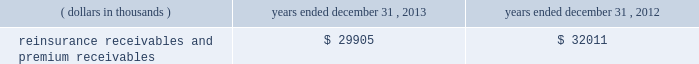In addition , the company has reclassified the following amounts from 201cdistributions from other invested assets 201d included in cash flows from investing activities to 201cdistribution of limited partnership income 201d included in cash flows from operations for interim reporting periods of 2013 : $ 33686 thousand for the three months ended march 31 , 2013 ; $ 9409 thousand and $ 43095 thousand for the three months and six months ended june 30 , 2013 , respectively ; and $ 5638 thousand and $ 48733 thousand for the three months and nine months ended september 30 , 2013 , respectively .
Investments .
Fixed maturity and equity security investments available for sale , at market value , reflect unrealized appreciation and depreciation , as a result of temporary changes in market value during the period , in shareholders 2019 equity , net of income taxes in 201caccumulated other comprehensive income ( loss ) 201d in the consolidated balance sheets .
Fixed maturity and equity securities carried at fair value reflect fair value re- measurements as net realized capital gains and losses in the consolidated statements of operations and comprehensive income ( loss ) .
The company records changes in fair value for its fixed maturities available for sale , at market value through shareholders 2019 equity , net of taxes in accumulated other comprehensive income ( loss ) since cash flows from these investments will be primarily used to settle its reserve for losses and loss adjustment expense liabilities .
The company anticipates holding these investments for an extended period as the cash flow from interest and maturities will fund the projected payout of these liabilities .
Fixed maturities carried at fair value represent a portfolio of convertible bond securities , which have characteristics similar to equity securities and at times , designated foreign denominated fixed maturity securities , which will be used to settle loss and loss adjustment reserves in the same currency .
The company carries all of its equity securities at fair value except for mutual fund investments whose underlying investments are comprised of fixed maturity securities .
For equity securities , available for sale , at fair value , the company reflects changes in value as net realized capital gains and losses since these securities may be sold in the near term depending on financial market conditions .
Interest income on all fixed maturities and dividend income on all equity securities are included as part of net investment income in the consolidated statements of operations and comprehensive income ( loss ) .
Unrealized losses on fixed maturities , which are deemed other-than-temporary and related to the credit quality of a security , are charged to net income ( loss ) as net realized capital losses .
Short-term investments are stated at cost , which approximates market value .
Realized gains or losses on sales of investments are determined on the basis of identified cost .
For non- publicly traded securities , market prices are determined through the use of pricing models that evaluate securities relative to the u.s .
Treasury yield curve , taking into account the issue type , credit quality , and cash flow characteristics of each security .
For publicly traded securities , market value is based on quoted market prices or valuation models that use observable market inputs .
When a sector of the financial markets is inactive or illiquid , the company may use its own assumptions about future cash flows and risk-adjusted discount rates to determine fair value .
Retrospective adjustments are employed to recalculate the values of asset-backed securities .
Each acquisition lot is reviewed to recalculate the effective yield .
The recalculated effective yield is used to derive a book value as if the new yield were applied at the time of acquisition .
Outstanding principal factors from the time of acquisition to the adjustment date are used to calculate the prepayment history for all applicable securities .
Conditional prepayment rates , computed with life to date factor histories and weighted average maturities , are used to effect the calculation of projected and prepayments for pass-through security types .
Other invested assets include limited partnerships , rabbi trusts and an affiliated entity .
Limited partnerships and the affiliated entity are accounted for under the equity method of accounting , which can be recorded on a monthly or quarterly lag .
Uncollectible receivable balances .
The company provides reserves for uncollectible reinsurance recoverable and premium receivable balances based on management 2019s assessment of the collectability of the outstanding balances .
Such reserves are presented in the table below for the periods indicated. .

For the years ended december 312013 and 2012 what was the percentage change in the reinsurance receivables and premium receivables? 
Computations: ((29905 - 32011) / 32011)
Answer: -0.06579. 